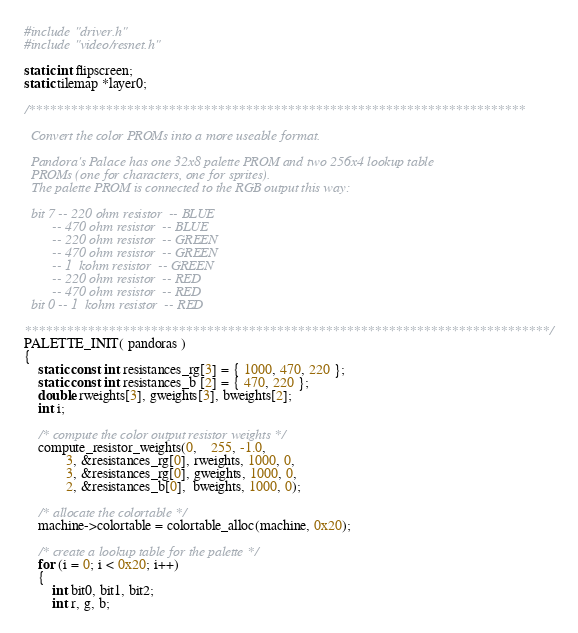Convert code to text. <code><loc_0><loc_0><loc_500><loc_500><_C_>#include "driver.h"
#include "video/resnet.h"

static int flipscreen;
static tilemap *layer0;

/***********************************************************************

  Convert the color PROMs into a more useable format.

  Pandora's Palace has one 32x8 palette PROM and two 256x4 lookup table
  PROMs (one for characters, one for sprites).
  The palette PROM is connected to the RGB output this way:

  bit 7 -- 220 ohm resistor  -- BLUE
        -- 470 ohm resistor  -- BLUE
        -- 220 ohm resistor  -- GREEN
        -- 470 ohm resistor  -- GREEN
        -- 1  kohm resistor  -- GREEN
        -- 220 ohm resistor  -- RED
        -- 470 ohm resistor  -- RED
  bit 0 -- 1  kohm resistor  -- RED

***************************************************************************/
PALETTE_INIT( pandoras )
{
	static const int resistances_rg[3] = { 1000, 470, 220 };
	static const int resistances_b [2] = { 470, 220 };
	double rweights[3], gweights[3], bweights[2];
	int i;

	/* compute the color output resistor weights */
	compute_resistor_weights(0,	255, -1.0,
			3, &resistances_rg[0], rweights, 1000, 0,
			3, &resistances_rg[0], gweights, 1000, 0,
			2, &resistances_b[0],  bweights, 1000, 0);

	/* allocate the colortable */
	machine->colortable = colortable_alloc(machine, 0x20);

	/* create a lookup table for the palette */
	for (i = 0; i < 0x20; i++)
	{
		int bit0, bit1, bit2;
		int r, g, b;
</code> 